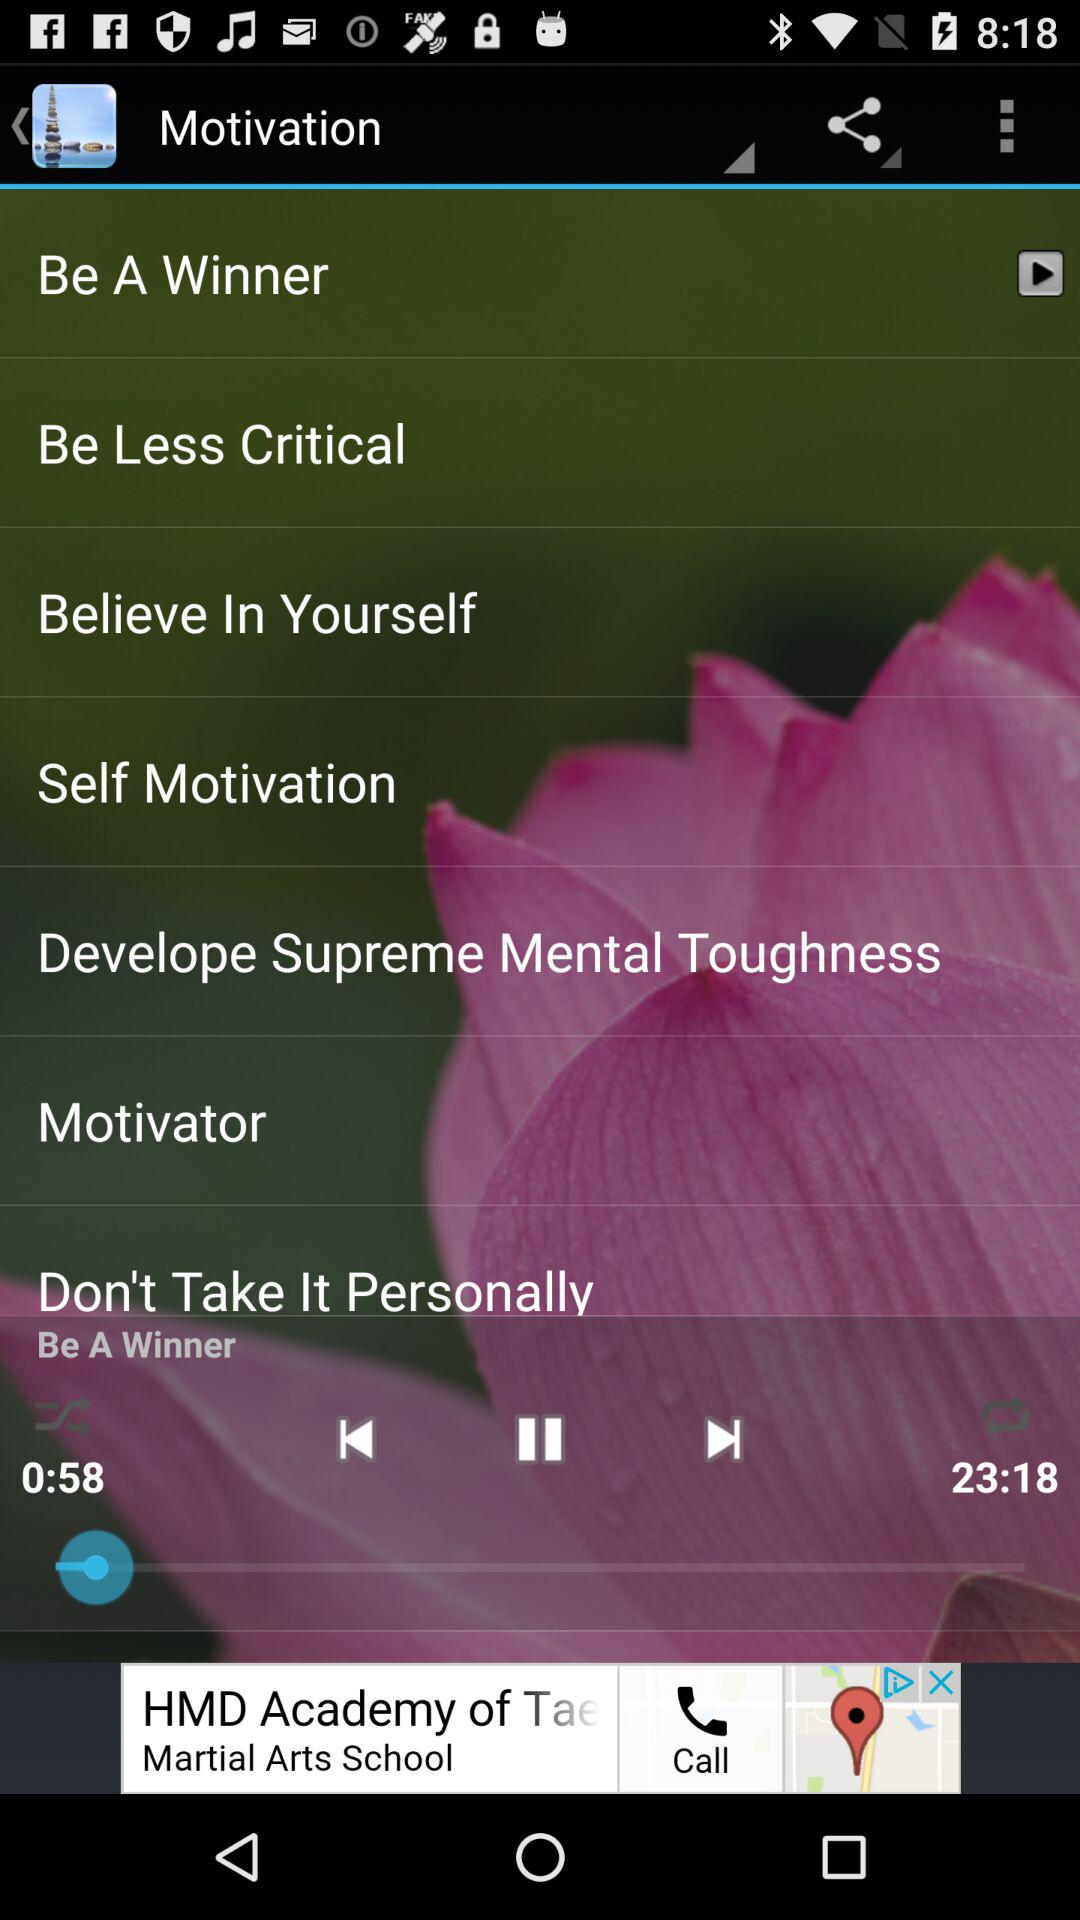What is the duration of the audio? The duration is 23 minutes 18 seconds. 